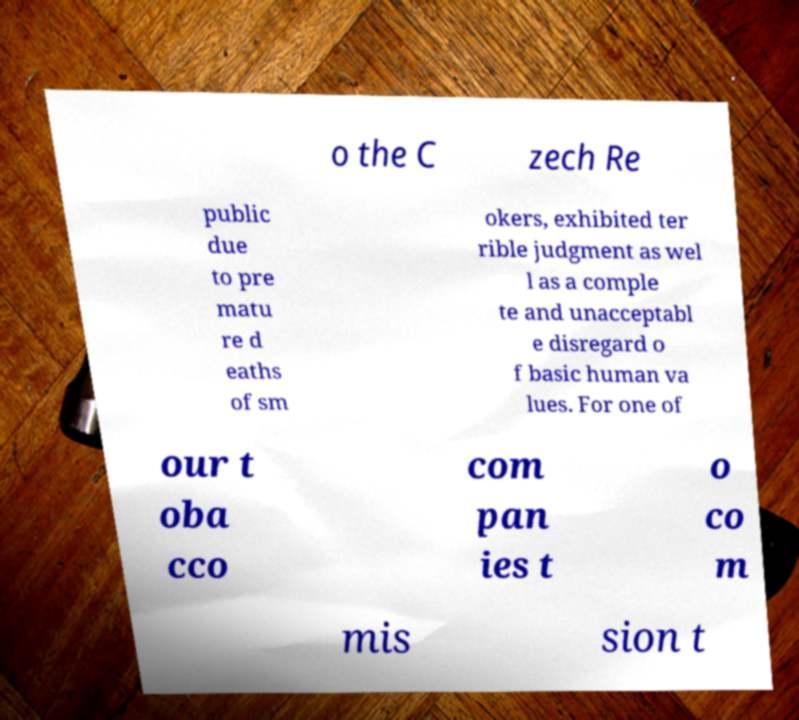Please identify and transcribe the text found in this image. o the C zech Re public due to pre matu re d eaths of sm okers, exhibited ter rible judgment as wel l as a comple te and unacceptabl e disregard o f basic human va lues. For one of our t oba cco com pan ies t o co m mis sion t 